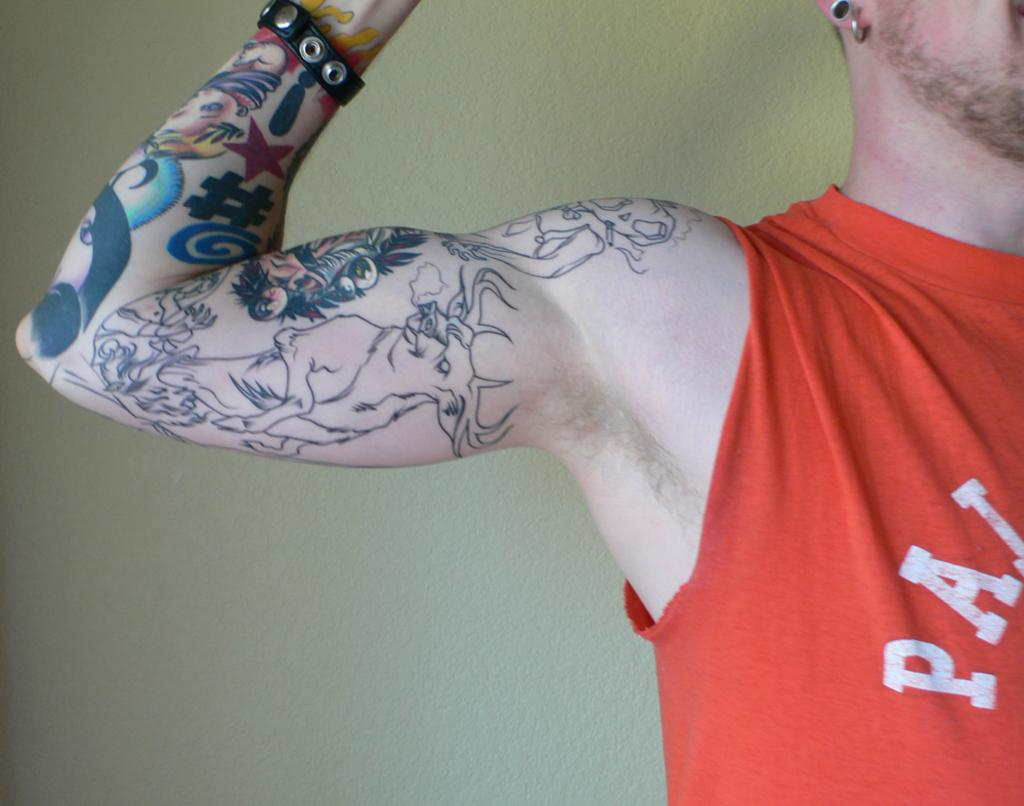What is the main subject of the image? There is a person in the image. What is the person wearing? The person is wearing an orange t-shirt. Are there any distinguishing features on the person's body? Yes, the person has a tattoo on their hand. What can be seen in the background of the image? There is a wall in the background of the image. How many vases are visible in the image? There are no vases present in the image. Can you describe the person's walking style in the image? The image does not show the person walking, so their walking style cannot be determined. 